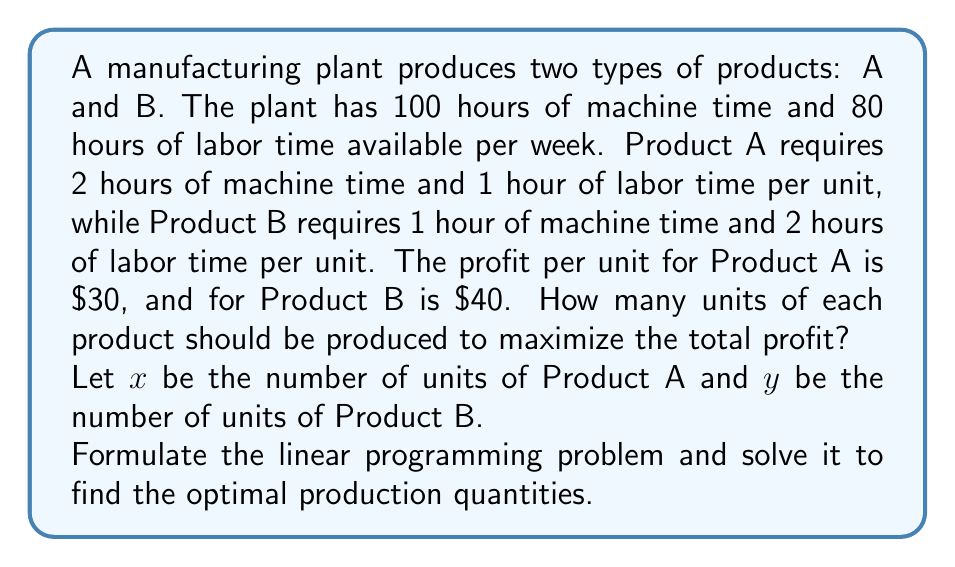Show me your answer to this math problem. To solve this problem, we'll follow these steps:

1. Formulate the linear programming problem:
   Objective function: Maximize $Z = 30x + 40y$
   Subject to constraints:
   $2x + y \leq 100$ (machine time constraint)
   $x + 2y \leq 80$ (labor time constraint)
   $x \geq 0, y \geq 0$ (non-negativity constraints)

2. Graph the constraints:
   [asy]
   import graph;
   size(200);
   xaxis("x", 0, 60);
   yaxis("y", 0, 60);
   draw((0,100)--(50,0), blue);
   draw((0,40)--(80,0), red);
   label("2x + y = 100", (25,50), N, blue);
   label("x + 2y = 80", (40,20), SE, red);
   fill((0,0)--(0,40)--(40,20)--(50,0)--cycle, lightgray);
   dot((0,40));
   dot((40,20));
   dot((50,0));
   label("(0,40)", (0,40), W);
   label("(40,20)", (40,20), E);
   label("(50,0)", (50,0), S);
   [/asy]

3. Identify the feasible region:
   The feasible region is the shaded area bounded by the constraints.

4. Find the corner points of the feasible region:
   (0,0), (0,40), (40,20), (50,0)

5. Evaluate the objective function at each corner point:
   At (0,0): $Z = 30(0) + 40(0) = 0$
   At (0,40): $Z = 30(0) + 40(40) = 1600$
   At (40,20): $Z = 30(40) + 40(20) = 2000$
   At (50,0): $Z = 30(50) + 40(0) = 1500$

6. Identify the optimal solution:
   The maximum value of Z occurs at the point (40,20), which gives the highest profit of $2000.

Therefore, the optimal production quantities are 40 units of Product A and 20 units of Product B.
Answer: The optimal production quantities are 40 units of Product A and 20 units of Product B, resulting in a maximum profit of $2000. 